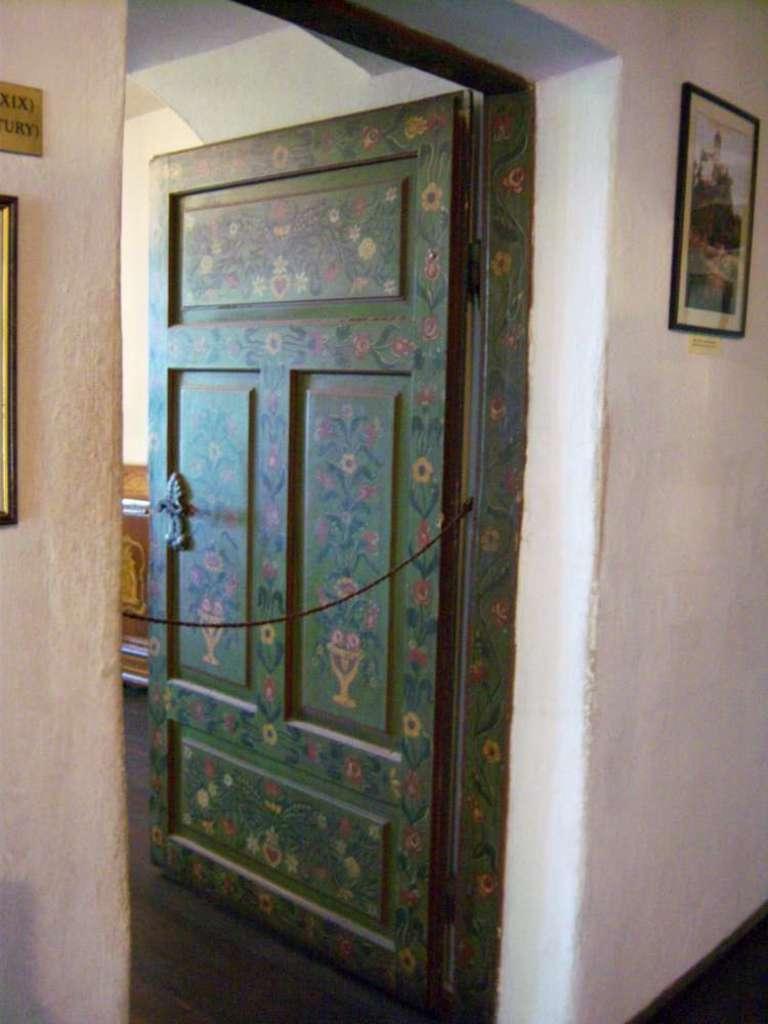How would you summarize this image in a sentence or two? In the center of the image we can see a door and there are frames placed on the wall. In the background there is an object. 